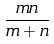Convert formula to latex. <formula><loc_0><loc_0><loc_500><loc_500>\frac { m n } { m + n }</formula> 